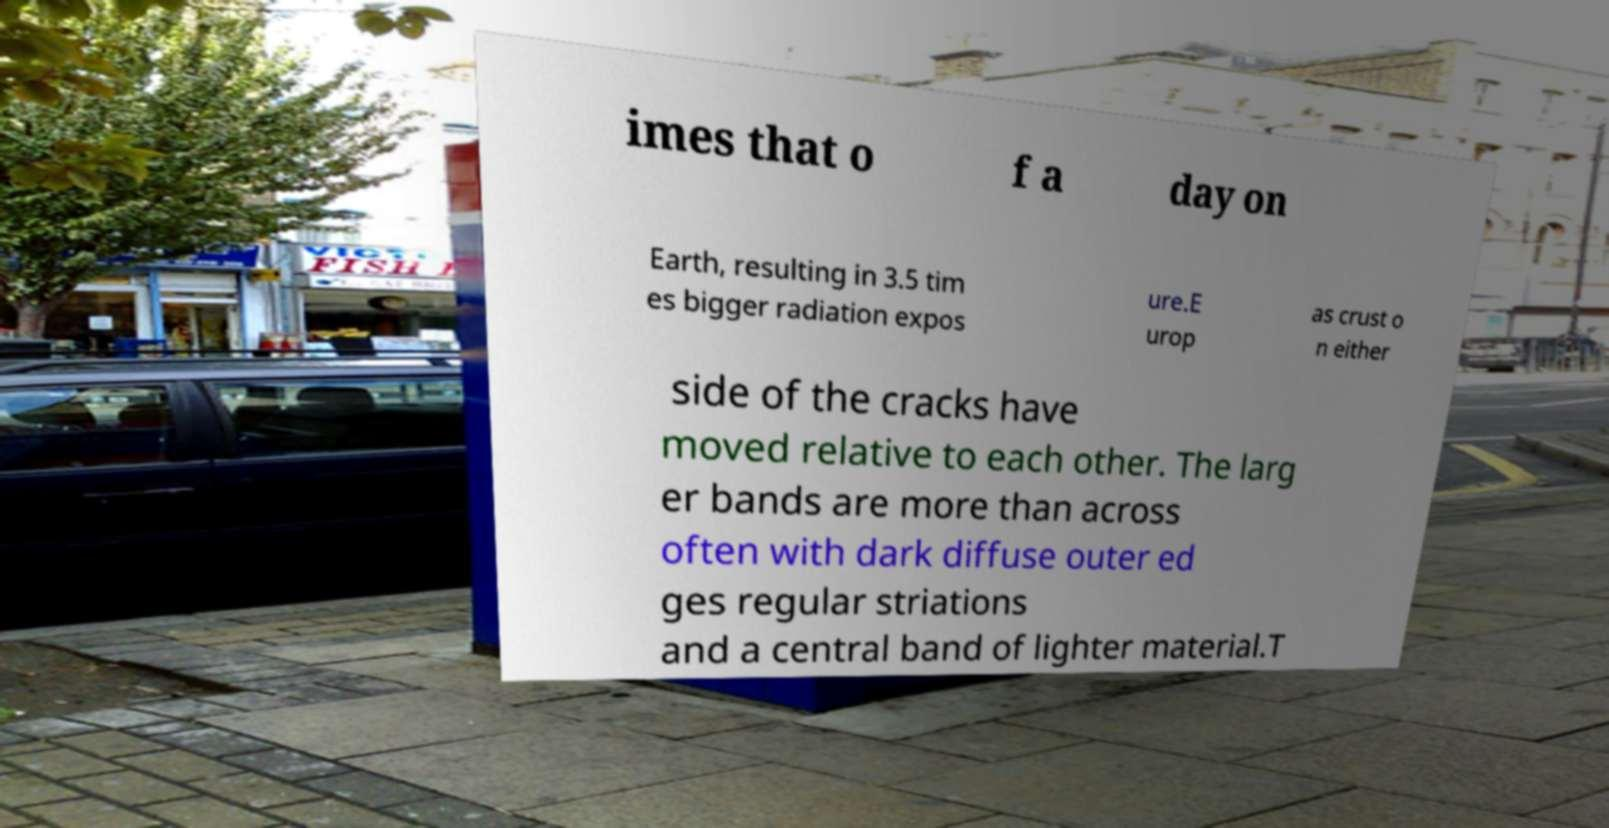Could you extract and type out the text from this image? imes that o f a day on Earth, resulting in 3.5 tim es bigger radiation expos ure.E urop as crust o n either side of the cracks have moved relative to each other. The larg er bands are more than across often with dark diffuse outer ed ges regular striations and a central band of lighter material.T 